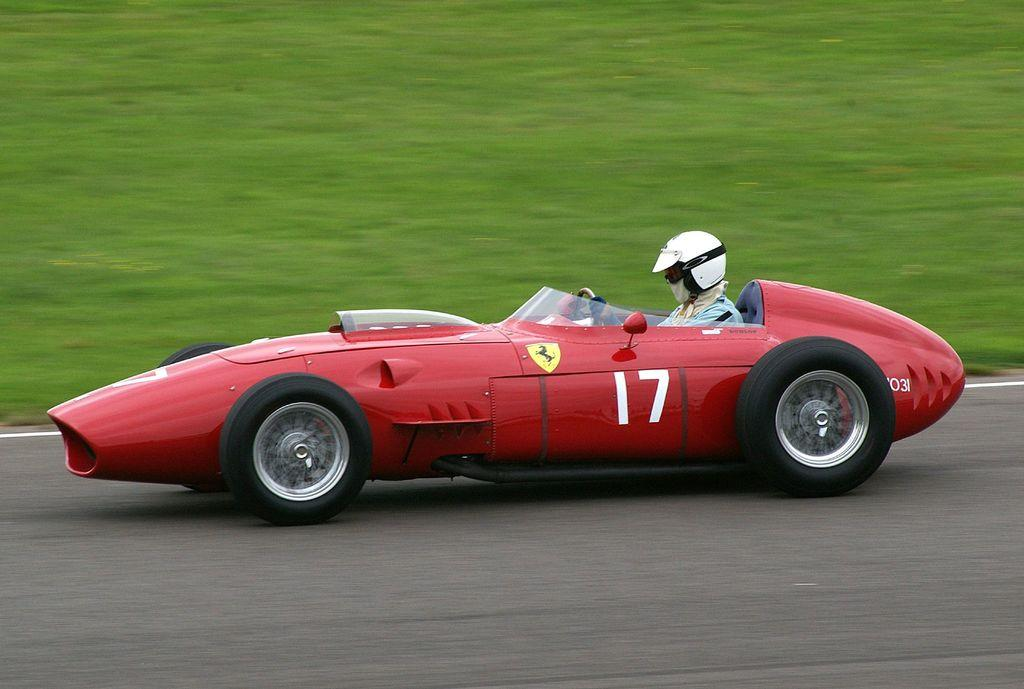What is the person in the image doing? There is a person riding a car in the image. Where is the car located? The car is on the road. Can you describe the background of the image? There is another car visible in the background of the image. What type of lipstick is the person wearing while riding the car in the image? There is no information about the person's lipstick in the image, so we cannot answer that question. 